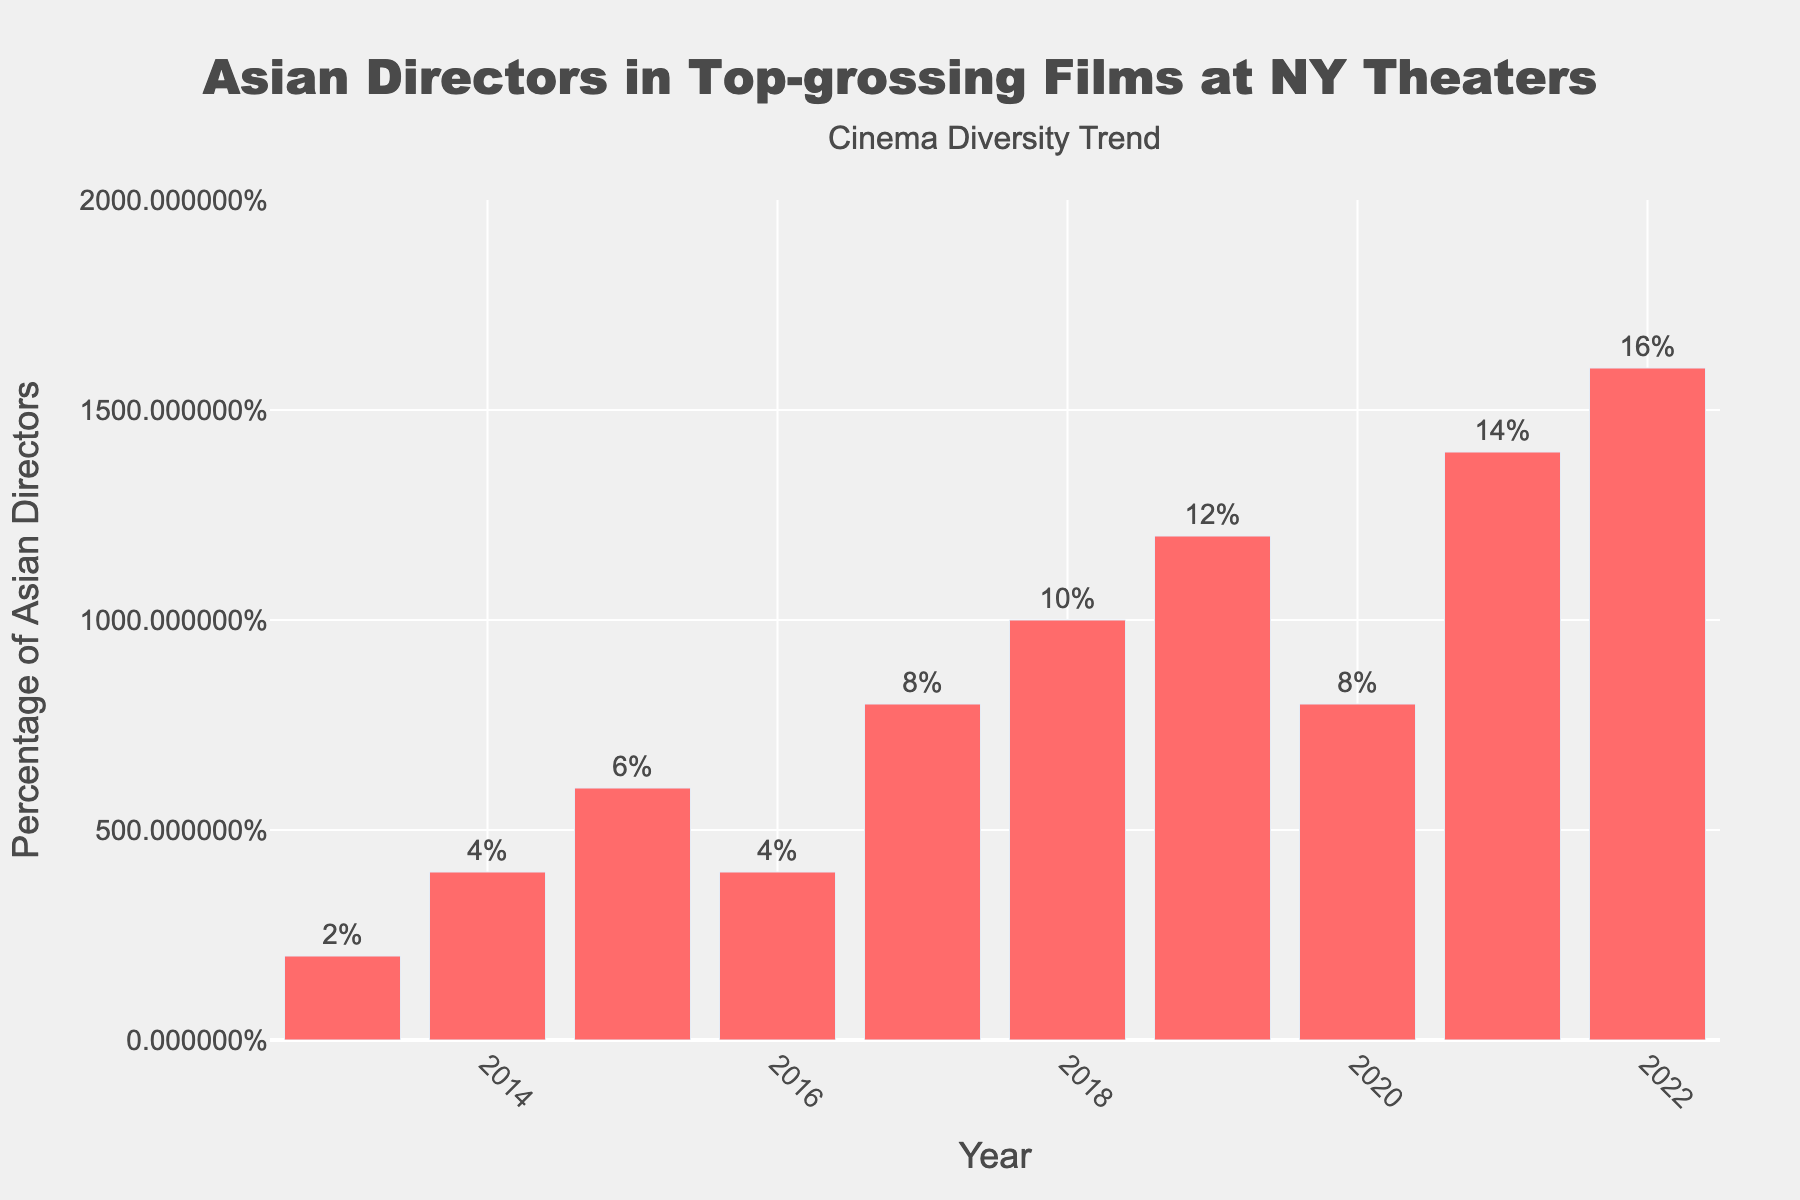What is the percentage of top-grossing films directed by Asian directors in 2022? Look at the bar corresponding to the year 2022 and note the height, which represents the percentage of top-grossing films directed by Asian directors in that year. The bar's text indicates "16%".
Answer: 16% Which year had the lowest percentage of Asian directors in top-grossing films? Identify the bar with the smallest height. The bar for the year 2013 is the shortest, with a percentage of 2%.
Answer: 2013 By how much did the percentage of films directed by Asian directors increase from 2013 to 2022? Subtract the percentage in 2013 (2%) from the percentage in 2022 (16%). The calculation is 16% - 2% = 14%.
Answer: 14% In which years was the percentage of Asian directors in top-grossing films 8%? Locate the bars with the text “8%”. These bars correspond to the years 2017 and 2020.
Answer: 2017 and 2020 What is the average percentage of Asian directors in top-grossing films from 2018 to 2022? Add the percentages for the years 2018 through 2022 and divide by the number of years: (10 + 12 + 8 + 14 + 16)% = 60%, divided by 5 years, results in an average of 12%.
Answer: 12% Between which consecutive years was the largest increase in the percentage of Asian directors observed? Calculate the difference in percentages year-over-year and identify the largest increase. The biggest jump occurred between 2020 (8%) and 2021 (14%) with an increase of 6%.
Answer: 2020 to 2021 If the trend continued, what would you expect the percentage of Asian directors to be in 2023? Considering an upward trend from previous years with average step increases, predict the expected percentage. The year-over-year increase from 2018 to 2022 is roughly 2%. Thus, 2023 might be expected around 18%.
Answer: 18% How many years saw a percentage increase from the previous year? Count the number of years where the percentage is higher than the preceding year. 2014, 2015, 2017, 2018, 2019, 2021, and 2022 are such years. There are 7 years in total.
Answer: 7 Which year saw the highest percentage of Asian directors in top-grossing films? Identify the tallest bar. The highest bar is for the year 2022 with 16%.
Answer: 2022 